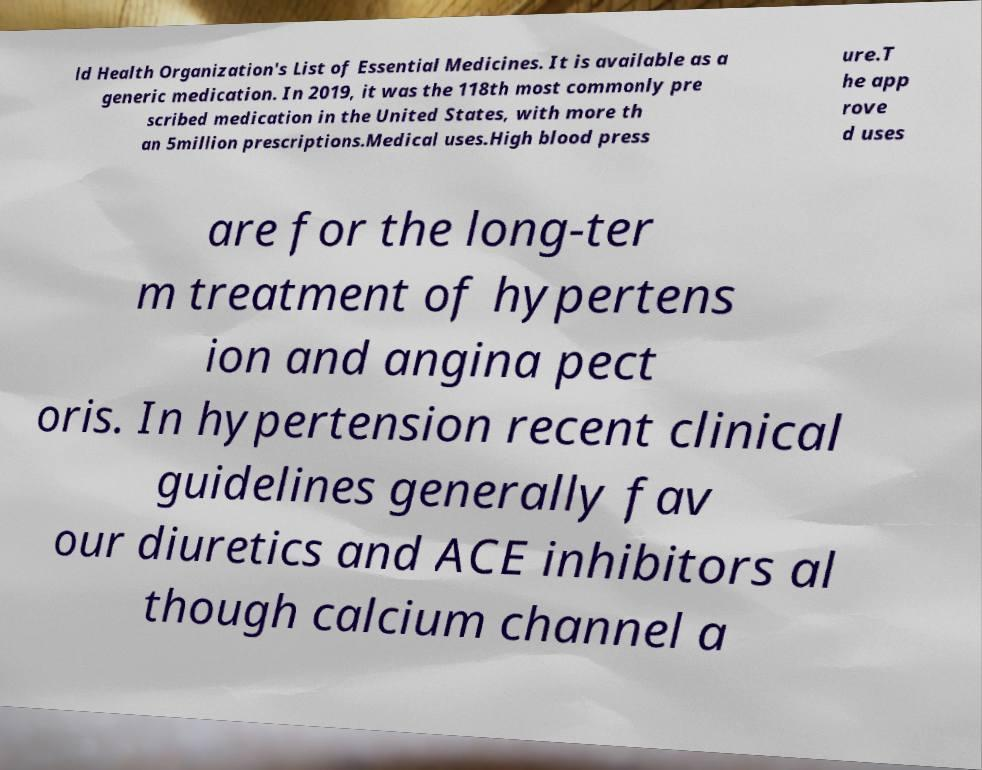There's text embedded in this image that I need extracted. Can you transcribe it verbatim? ld Health Organization's List of Essential Medicines. It is available as a generic medication. In 2019, it was the 118th most commonly pre scribed medication in the United States, with more th an 5million prescriptions.Medical uses.High blood press ure.T he app rove d uses are for the long-ter m treatment of hypertens ion and angina pect oris. In hypertension recent clinical guidelines generally fav our diuretics and ACE inhibitors al though calcium channel a 